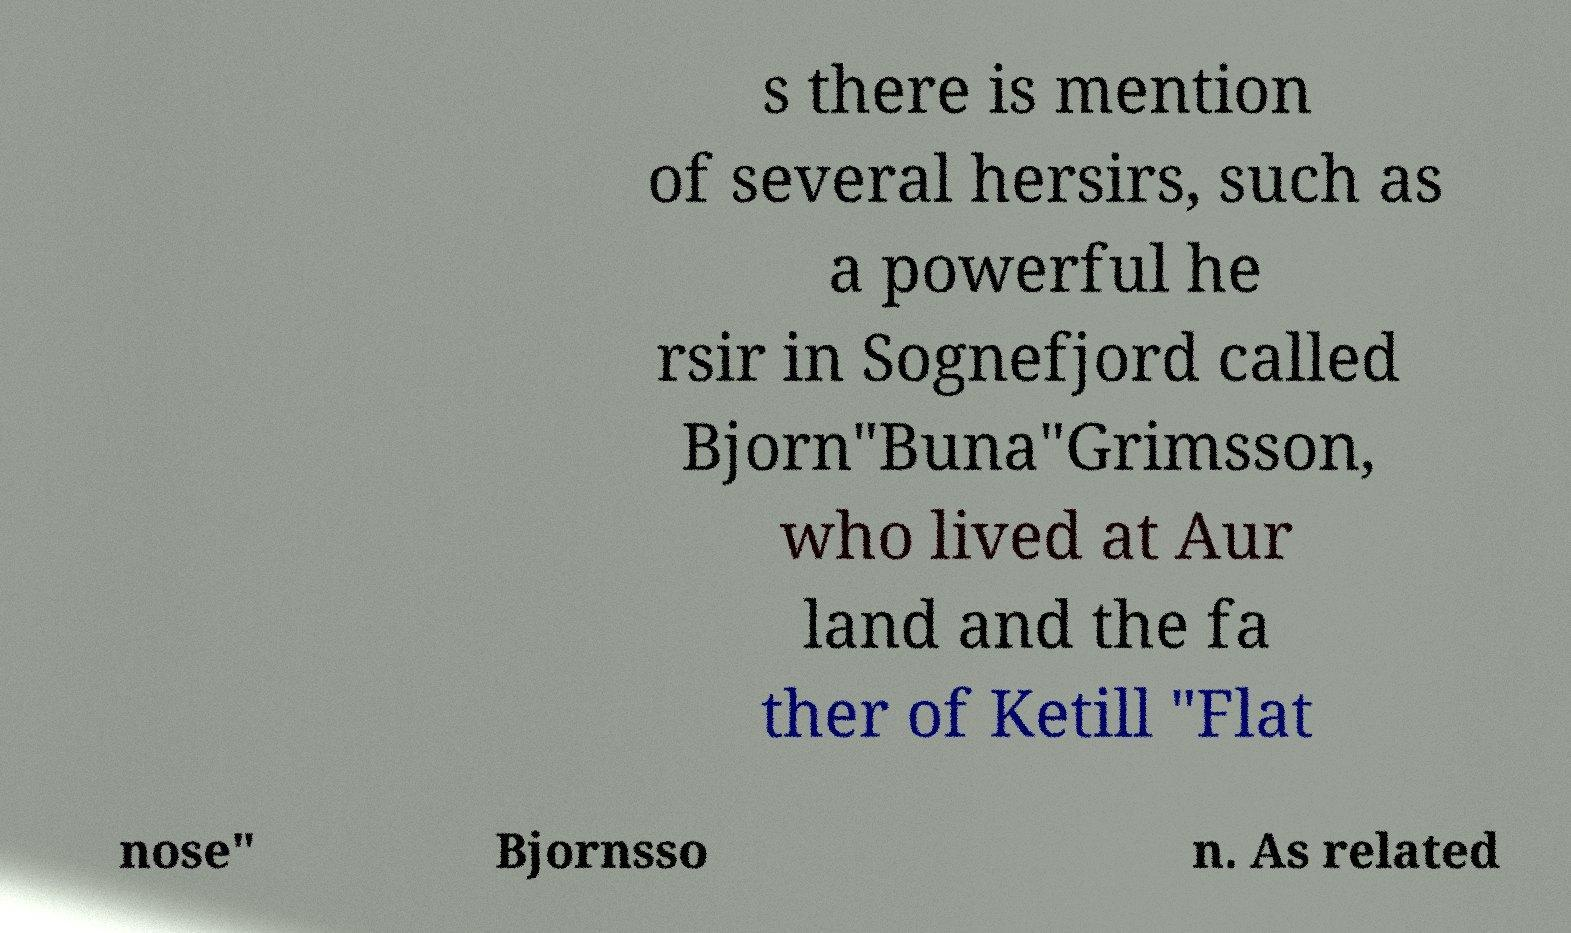There's text embedded in this image that I need extracted. Can you transcribe it verbatim? s there is mention of several hersirs, such as a powerful he rsir in Sognefjord called Bjorn"Buna"Grimsson, who lived at Aur land and the fa ther of Ketill "Flat nose" Bjornsso n. As related 